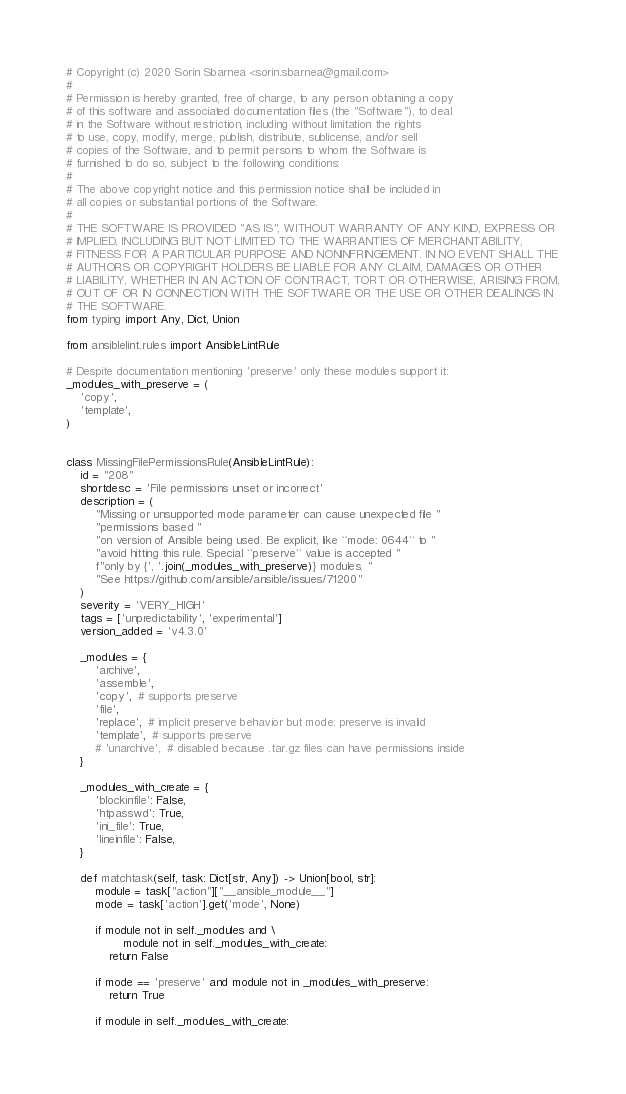<code> <loc_0><loc_0><loc_500><loc_500><_Python_># Copyright (c) 2020 Sorin Sbarnea <sorin.sbarnea@gmail.com>
#
# Permission is hereby granted, free of charge, to any person obtaining a copy
# of this software and associated documentation files (the "Software"), to deal
# in the Software without restriction, including without limitation the rights
# to use, copy, modify, merge, publish, distribute, sublicense, and/or sell
# copies of the Software, and to permit persons to whom the Software is
# furnished to do so, subject to the following conditions:
#
# The above copyright notice and this permission notice shall be included in
# all copies or substantial portions of the Software.
#
# THE SOFTWARE IS PROVIDED "AS IS", WITHOUT WARRANTY OF ANY KIND, EXPRESS OR
# IMPLIED, INCLUDING BUT NOT LIMITED TO THE WARRANTIES OF MERCHANTABILITY,
# FITNESS FOR A PARTICULAR PURPOSE AND NONINFRINGEMENT. IN NO EVENT SHALL THE
# AUTHORS OR COPYRIGHT HOLDERS BE LIABLE FOR ANY CLAIM, DAMAGES OR OTHER
# LIABILITY, WHETHER IN AN ACTION OF CONTRACT, TORT OR OTHERWISE, ARISING FROM,
# OUT OF OR IN CONNECTION WITH THE SOFTWARE OR THE USE OR OTHER DEALINGS IN
# THE SOFTWARE.
from typing import Any, Dict, Union

from ansiblelint.rules import AnsibleLintRule

# Despite documentation mentioning 'preserve' only these modules support it:
_modules_with_preserve = (
    'copy',
    'template',
)


class MissingFilePermissionsRule(AnsibleLintRule):
    id = "208"
    shortdesc = 'File permissions unset or incorrect'
    description = (
        "Missing or unsupported mode parameter can cause unexpected file "
        "permissions based "
        "on version of Ansible being used. Be explicit, like ``mode: 0644`` to "
        "avoid hitting this rule. Special ``preserve`` value is accepted "
        f"only by {', '.join(_modules_with_preserve)} modules. "
        "See https://github.com/ansible/ansible/issues/71200"
    )
    severity = 'VERY_HIGH'
    tags = ['unpredictability', 'experimental']
    version_added = 'v4.3.0'

    _modules = {
        'archive',
        'assemble',
        'copy',  # supports preserve
        'file',
        'replace',  # implicit preserve behavior but mode: preserve is invalid
        'template',  # supports preserve
        # 'unarchive',  # disabled because .tar.gz files can have permissions inside
    }

    _modules_with_create = {
        'blockinfile': False,
        'htpasswd': True,
        'ini_file': True,
        'lineinfile': False,
    }

    def matchtask(self, task: Dict[str, Any]) -> Union[bool, str]:
        module = task["action"]["__ansible_module__"]
        mode = task['action'].get('mode', None)

        if module not in self._modules and \
                module not in self._modules_with_create:
            return False

        if mode == 'preserve' and module not in _modules_with_preserve:
            return True

        if module in self._modules_with_create:</code> 